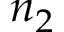Convert formula to latex. <formula><loc_0><loc_0><loc_500><loc_500>n _ { 2 }</formula> 